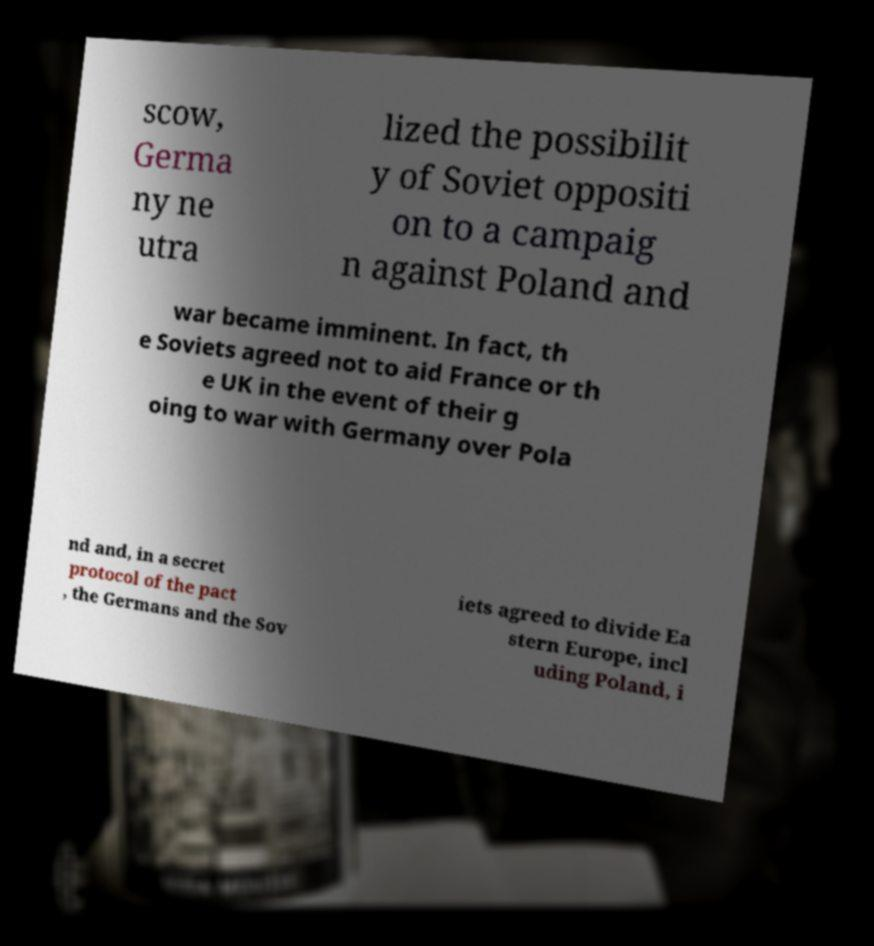Could you extract and type out the text from this image? scow, Germa ny ne utra lized the possibilit y of Soviet oppositi on to a campaig n against Poland and war became imminent. In fact, th e Soviets agreed not to aid France or th e UK in the event of their g oing to war with Germany over Pola nd and, in a secret protocol of the pact , the Germans and the Sov iets agreed to divide Ea stern Europe, incl uding Poland, i 